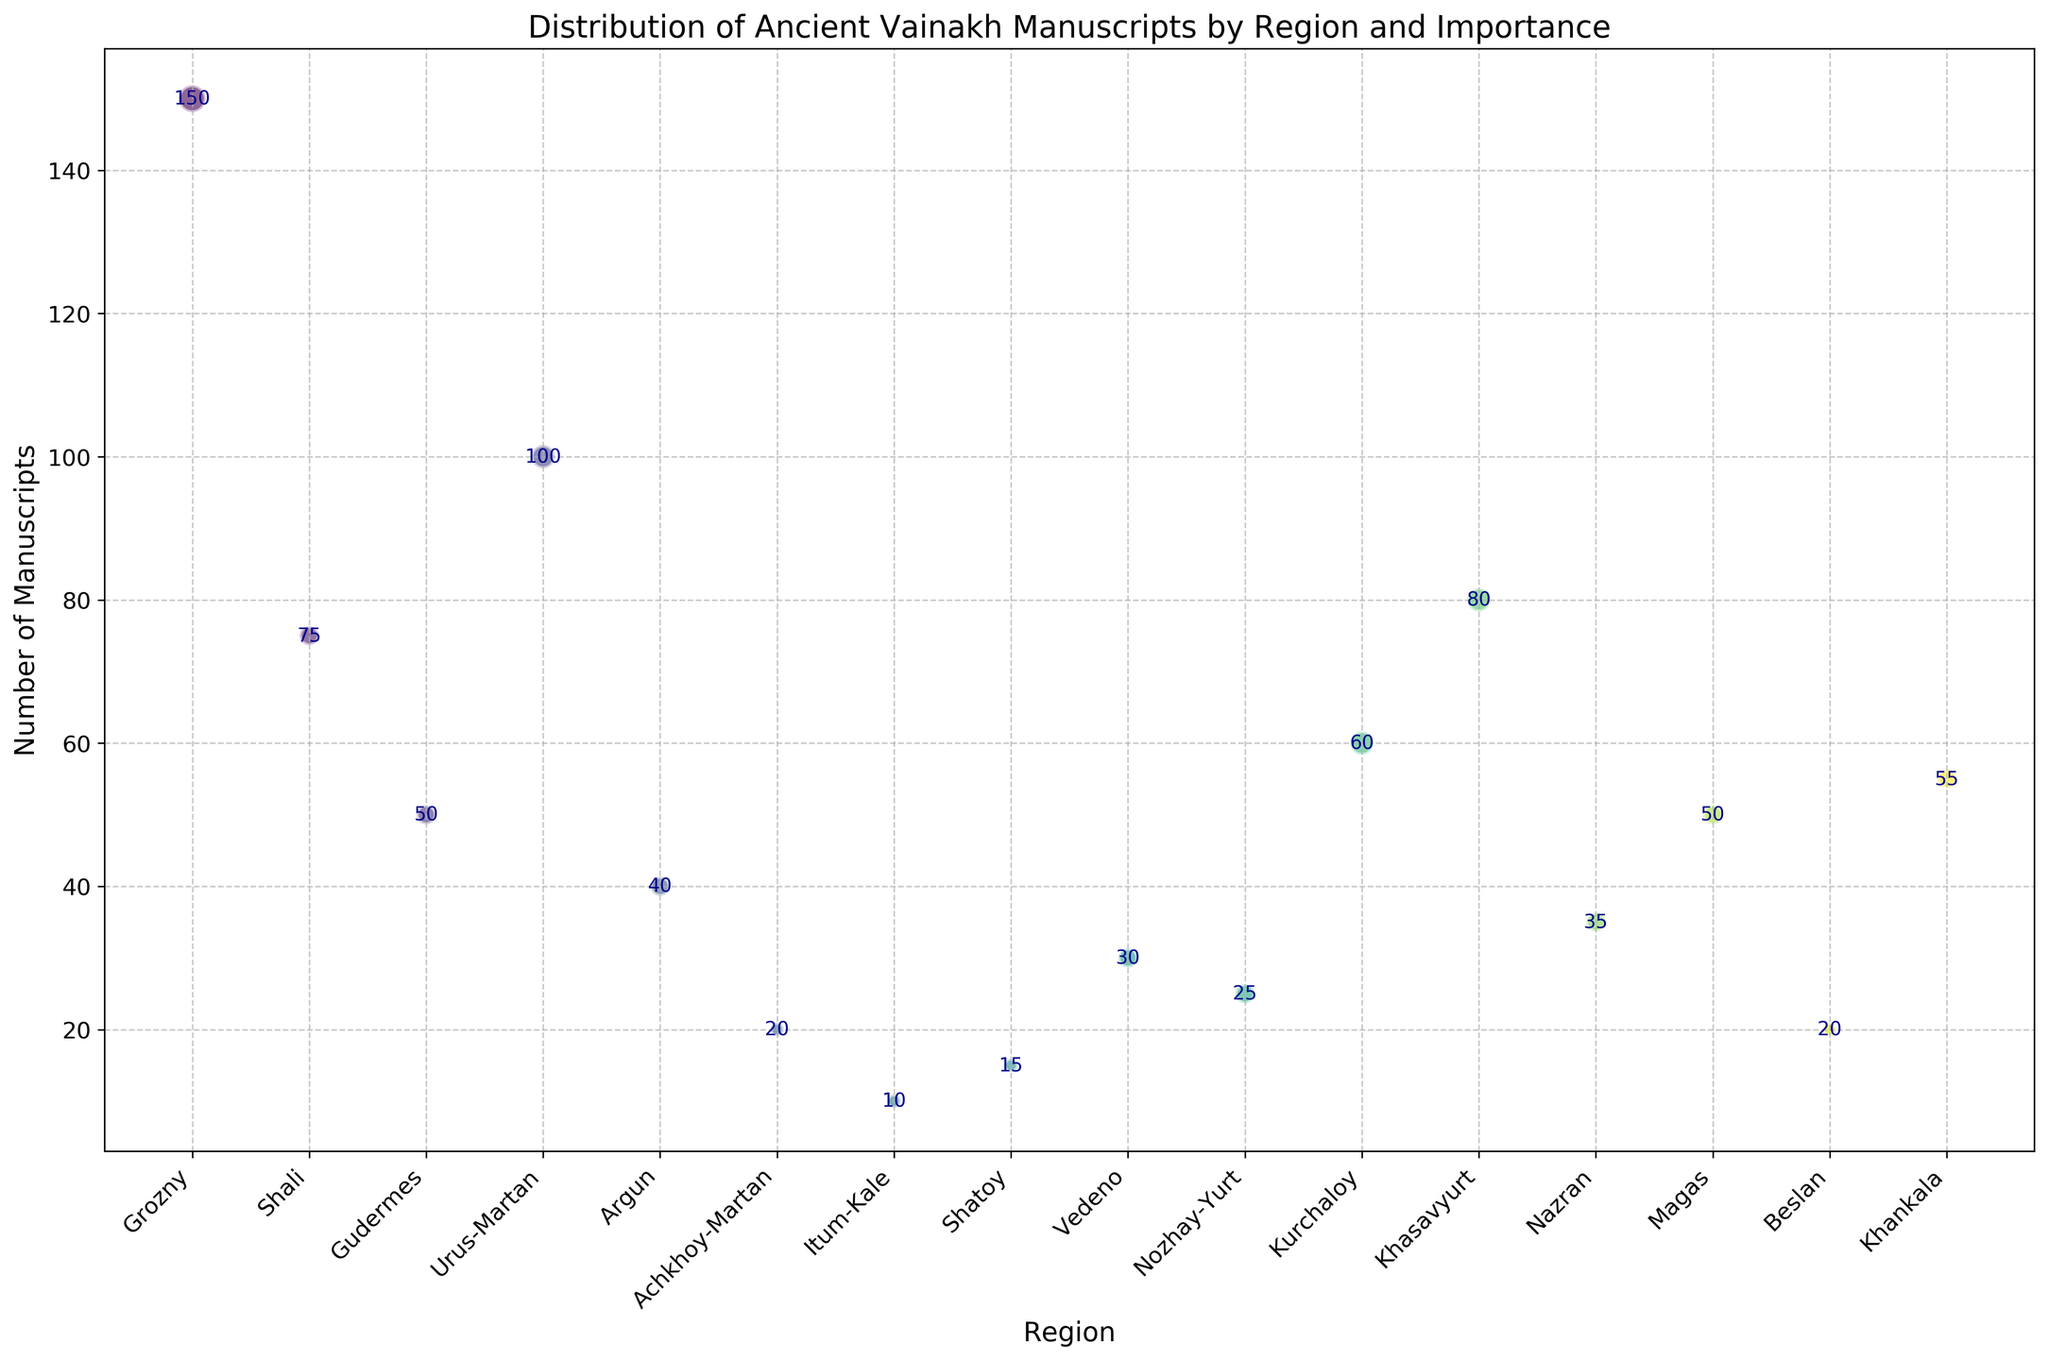Which region has the highest number of ancient Vainakh manuscripts? By looking at the figure, the region with the highest point on the y-axis is Grozny, which has 150 manuscripts as indicated by the corresponding text label.
Answer: Grozny Compare Khasavyurt and Kurchaloy in terms of the number of manuscripts. Which region has more? By observing the height of the points, Khasavyurt has a higher point on the y-axis (80 manuscripts) compared to Kurchaloy (60 manuscripts).
Answer: Khasavyurt Of the regions with 'Medium-High' importance, which one has the least number of manuscripts? The 'Medium-High' importance size bubbles are linked to regions Urus-Martan, Khasavyurt, and Kurchaloy. Among these, Kurchaloy has the least number of manuscripts with 60.
Answer: Kurchaloy What is the combined number of manuscripts in regions with 'Low' importance? The regions with 'Low' importance include Achkhoy-Martan (20), Itum-Kale (10), Shatoy (15), and Beslan (20). Summing these up: 20 + 10 + 15 + 20 = 65.
Answer: 65 Could you find the region whose number of manuscripts is closest to the average of all manuscripts provided? First, calculate the total number of manuscripts: 150 + 75 + 50 + 100 + 40 + 20 + 10 + 15 + 30 + 25 + 60 + 80 + 35 + 50 + 20 + 55 = 815. 
Number of regions = 16. 
Average number of manuscripts = 815 / 16 ≈ 50.9.
From the figure, regions with manuscript numbers close to 50 are Gudermes and Magas, both having 50. The closest is Gudermes and Magas.
Answer: Gudermes, Magas 